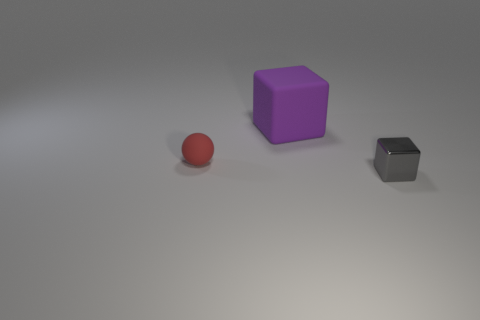Add 2 rubber spheres. How many objects exist? 5 Subtract all cubes. How many objects are left? 1 Add 3 metal objects. How many metal objects are left? 4 Add 2 small yellow cubes. How many small yellow cubes exist? 2 Subtract 0 purple cylinders. How many objects are left? 3 Subtract all cyan metallic spheres. Subtract all shiny cubes. How many objects are left? 2 